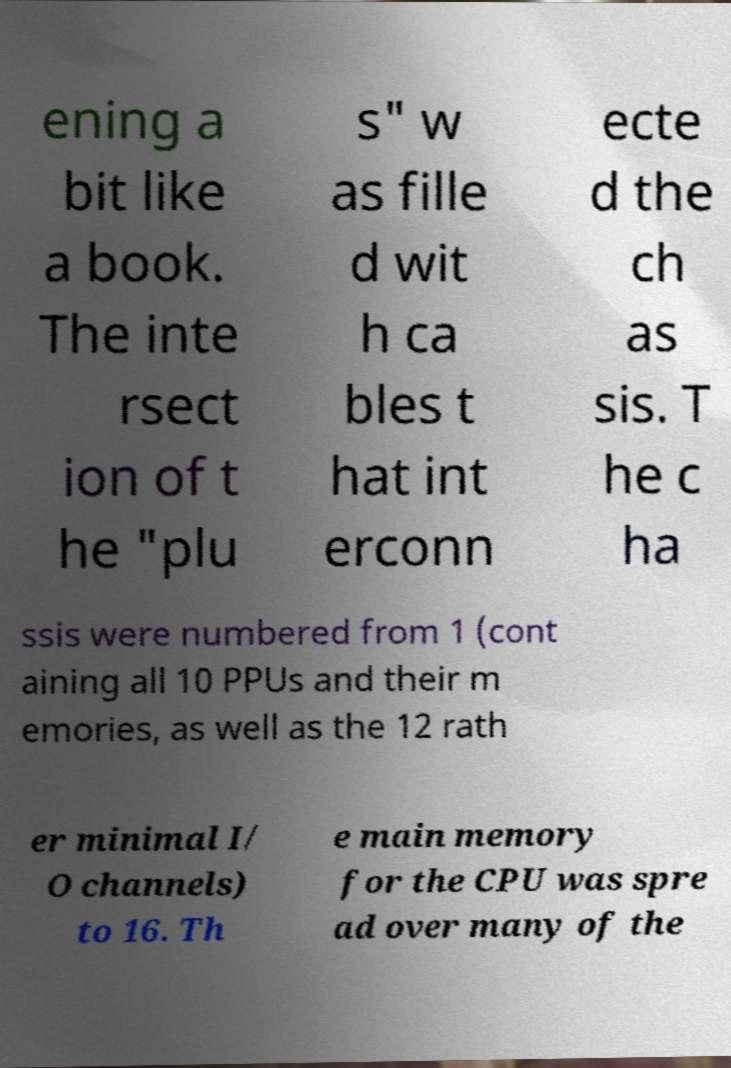I need the written content from this picture converted into text. Can you do that? ening a bit like a book. The inte rsect ion of t he "plu s" w as fille d wit h ca bles t hat int erconn ecte d the ch as sis. T he c ha ssis were numbered from 1 (cont aining all 10 PPUs and their m emories, as well as the 12 rath er minimal I/ O channels) to 16. Th e main memory for the CPU was spre ad over many of the 